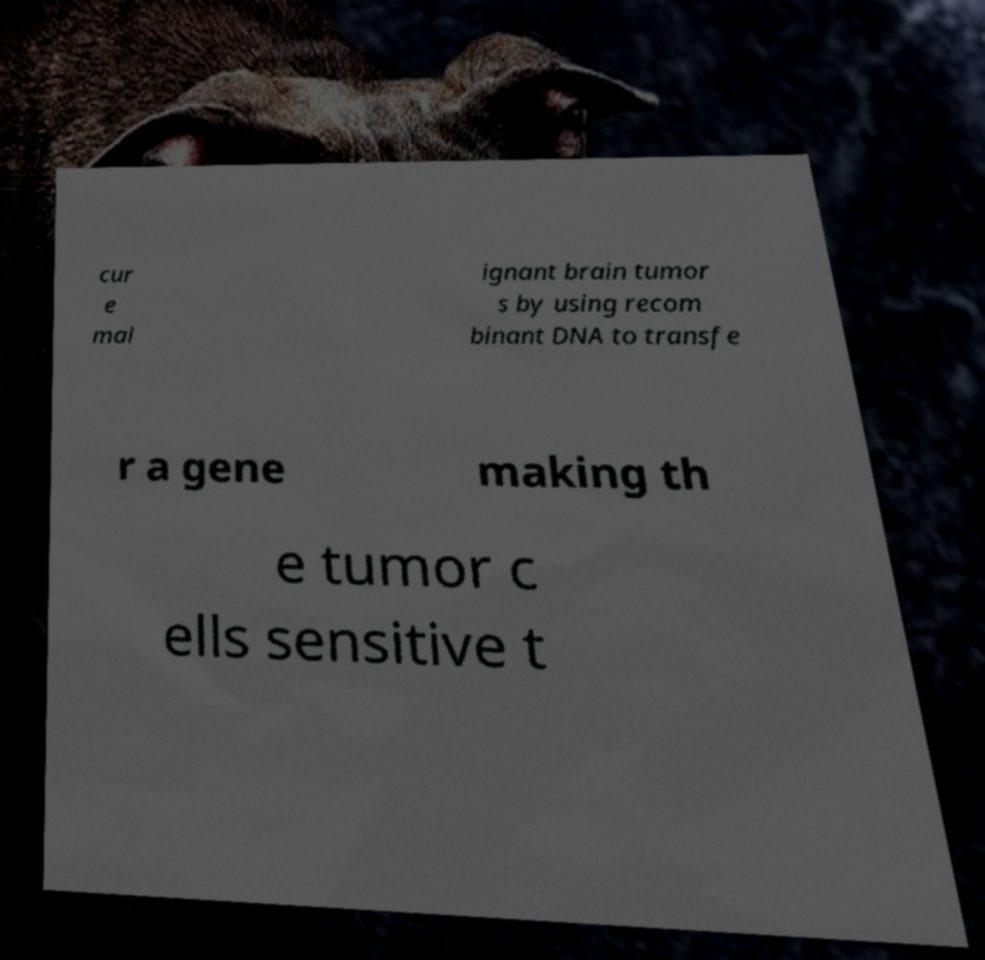I need the written content from this picture converted into text. Can you do that? cur e mal ignant brain tumor s by using recom binant DNA to transfe r a gene making th e tumor c ells sensitive t 